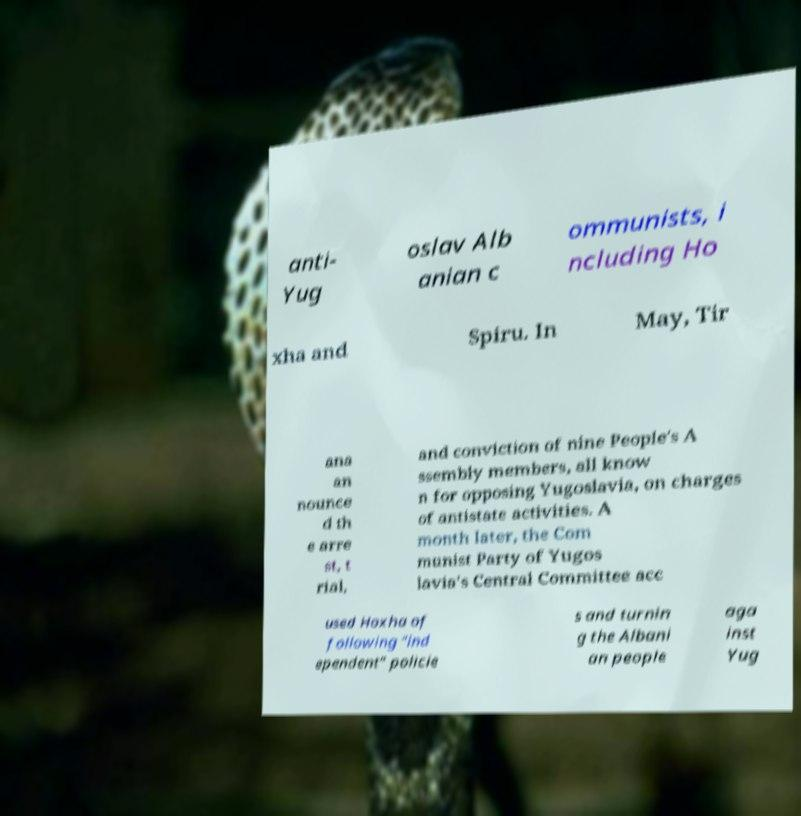Please identify and transcribe the text found in this image. anti- Yug oslav Alb anian c ommunists, i ncluding Ho xha and Spiru. In May, Tir ana an nounce d th e arre st, t rial, and conviction of nine People's A ssembly members, all know n for opposing Yugoslavia, on charges of antistate activities. A month later, the Com munist Party of Yugos lavia's Central Committee acc used Hoxha of following "ind ependent" policie s and turnin g the Albani an people aga inst Yug 